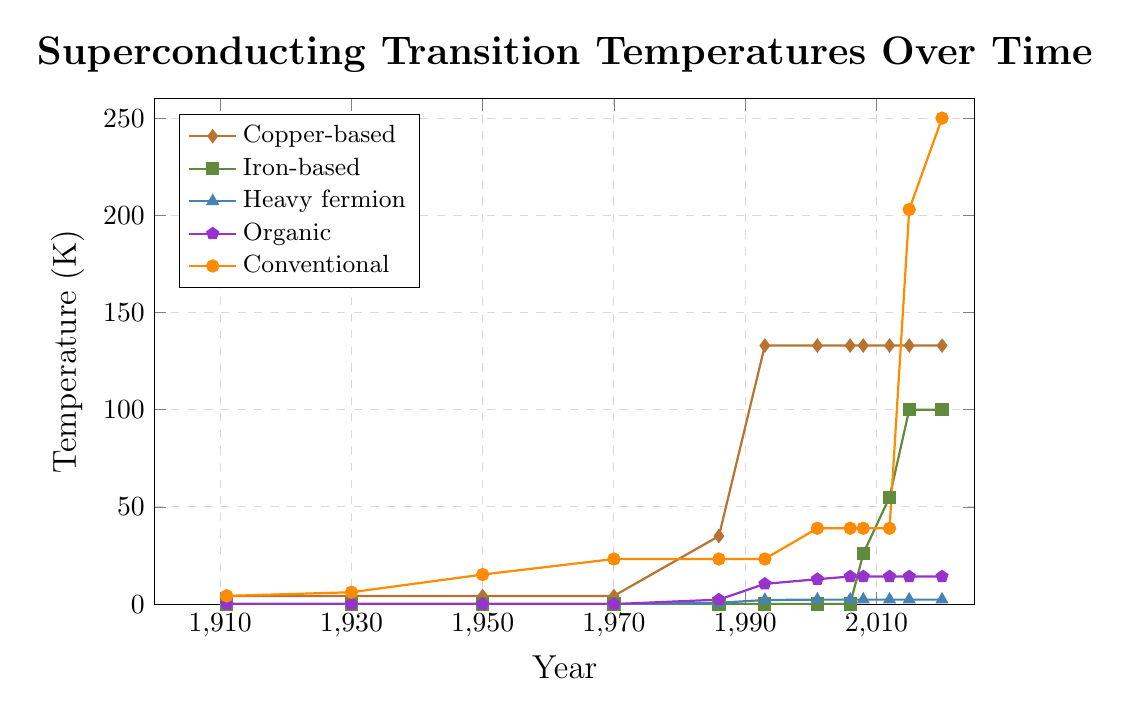What is the highest superconducting transition temperature recorded in the dataset for conventional materials? The highest superconducting transition temperature for conventional materials occurs at the latest year in the dataset (2020), with a value of 250 K.
Answer: 250 K What are the years in which Copper-based materials showed a significant increase in superconducting transition temperature? Copper-based materials showed a significant increase in 1986 (from 4.2 K to 35 K) and in 1993 (from 35 K to 133 K).
Answer: 1986, 1993 Between which years did Iron-based materials first show a superconducting transition temperature greater than zero? Iron-based materials first showed a superconducting transition temperature greater than zero in the year 2008. Prior to that, the temperature was zero.
Answer: Between 2006 and 2008 What was the superconducting transition temperature for Organic materials in 2012? In 2012, the superconducting transition temperature for Organic materials was 14.2 K.
Answer: 14.2 K Which material family had a constant superconducting transition temperature from 2001 to 2020? Heavy fermion materials had a constant superconducting transition temperature of 2.3 K from 2001 to 2020.
Answer: Heavy fermion By how much did the superconducting transition temperature increase for Iron-based materials from 2008 to 2012? The superconducting transition temperature for Iron-based materials increased from 26 K in 2008 to 55 K in 2012. This is an increase of 29 K.
Answer: 29 K How did the superconducting transition temperature for conventional materials change from 1950 to 2020? The superconducting transition temperature for conventional materials increased from 15.2 K in 1950 to 250 K in 2020. The change is 250 K - 15.2 K = 234.8 K.
Answer: 234.8 K Which materials had their highest recorded superconducting transition temperature before 2000? Both Copper-based materials (133 K in 1993) and Heavy fermion materials (2.3 K in 2001) had their highest recorded temperatures before 2000.
Answer: Copper-based, Heavy fermion 